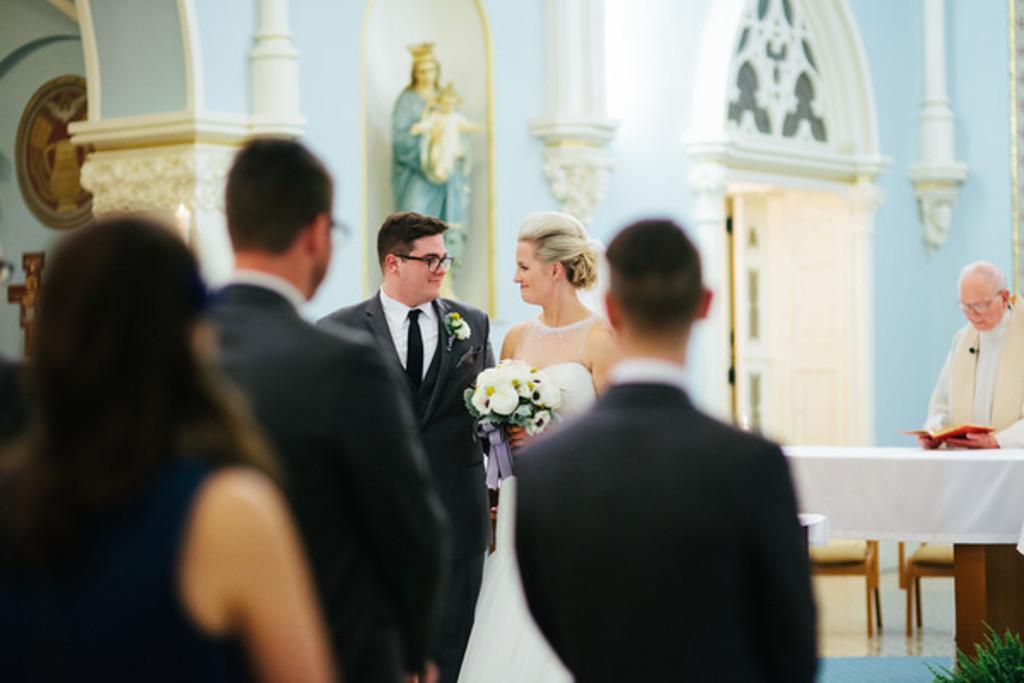Could you give a brief overview of what you see in this image? In this image, I can see few people standing. There is a woman holding a flower bouquet. On the right side of the image, I can see the chairs and a table covered with a cloth. In the background, I can see a sculpture, wall, door and few objects. 